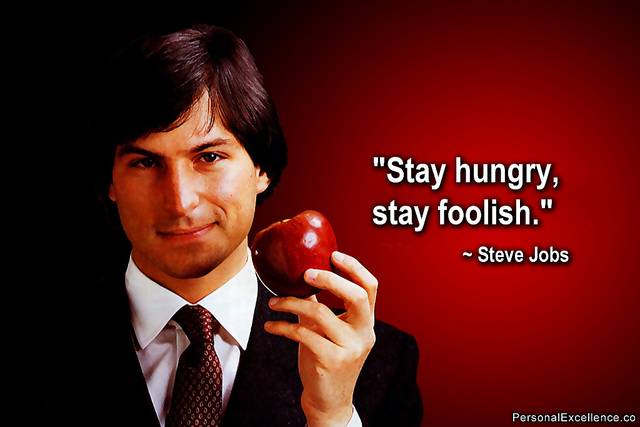Please identify all text content in this image. 'Stay hungry stay foolish Steve PersonalExcellence.co Jobs 